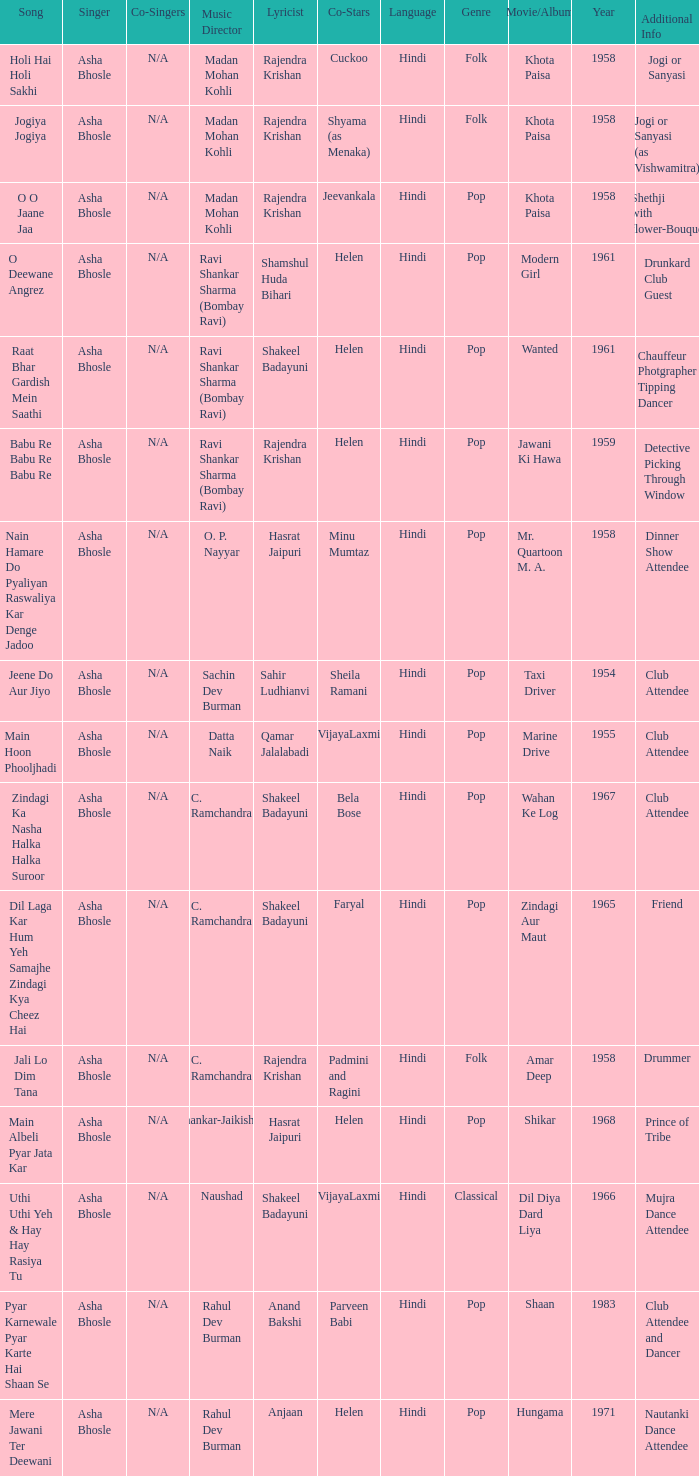What year did Naushad Direct the Music? 1966.0. 